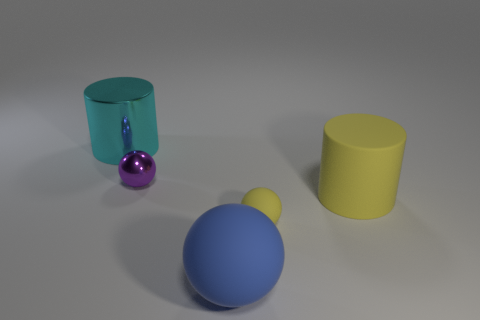There is a ball that is behind the tiny matte object; what is its size?
Provide a succinct answer. Small. There is a blue matte object that is in front of the cylinder in front of the metal cylinder; what is its size?
Ensure brevity in your answer.  Large. There is a yellow object that is the same size as the metal ball; what material is it?
Ensure brevity in your answer.  Rubber. Are there any metal objects in front of the large cyan metal object?
Offer a terse response. Yes. Is the number of tiny purple metallic things in front of the small matte thing the same as the number of small purple balls?
Your answer should be very brief. No. The rubber object that is the same size as the yellow matte cylinder is what shape?
Keep it short and to the point. Sphere. What material is the purple object?
Make the answer very short. Metal. What is the color of the large object that is on the right side of the cyan shiny cylinder and behind the large blue object?
Provide a short and direct response. Yellow. Are there an equal number of big cyan metal cylinders that are right of the yellow rubber ball and tiny purple metallic spheres that are to the left of the purple shiny object?
Your answer should be compact. Yes. What color is the large object that is the same material as the large sphere?
Provide a succinct answer. Yellow. 